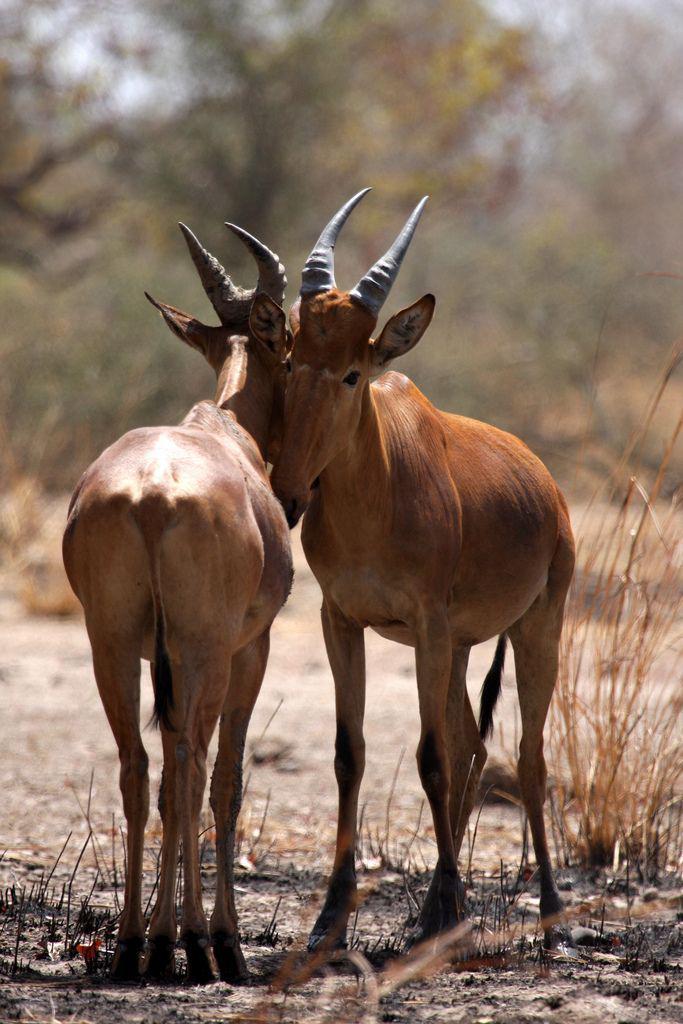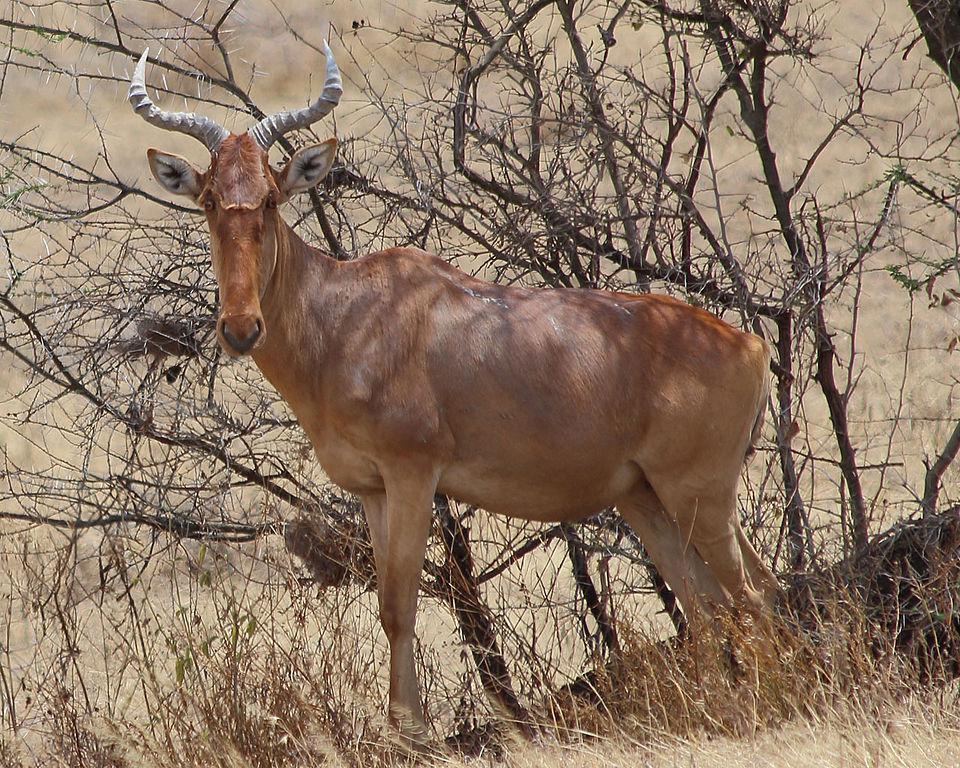The first image is the image on the left, the second image is the image on the right. Given the left and right images, does the statement "There are less than four animals with horns visible." hold true? Answer yes or no. Yes. The first image is the image on the left, the second image is the image on the right. Given the left and right images, does the statement "Two of the animals are standing close together with heads high facing opposite directions." hold true? Answer yes or no. Yes. 